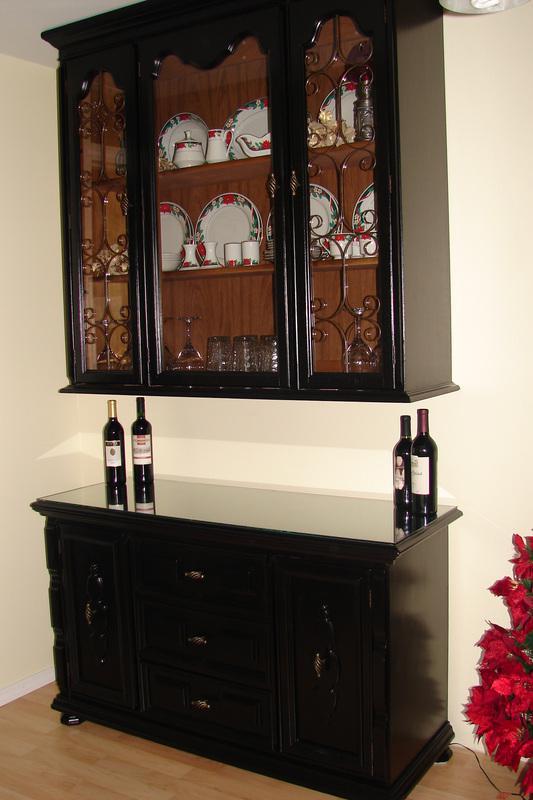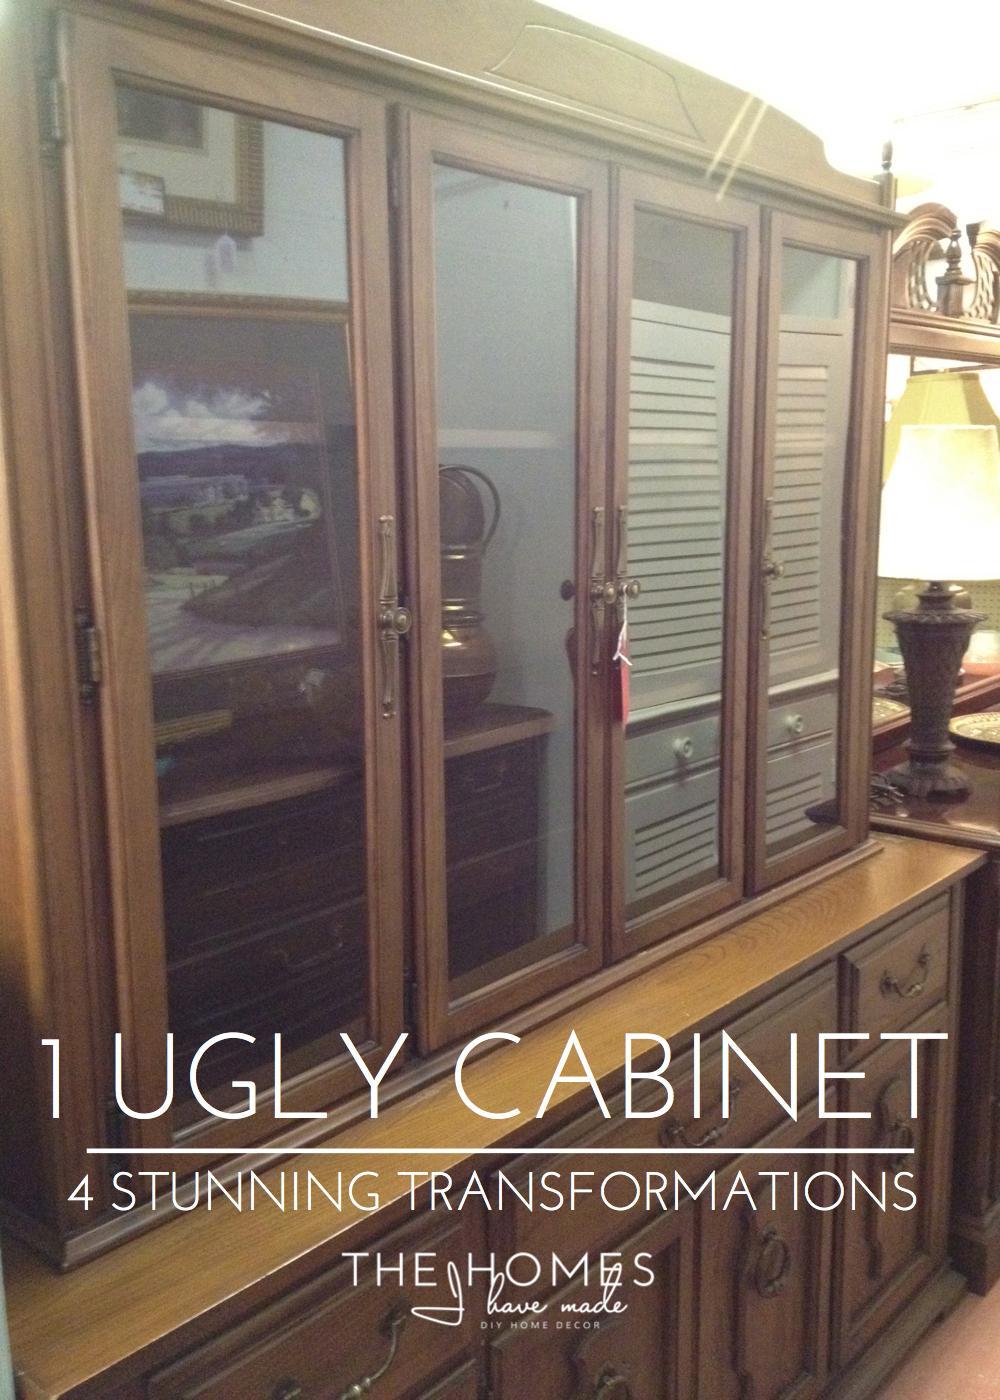The first image is the image on the left, the second image is the image on the right. Assess this claim about the two images: "One of the images includes warm-colored flowers.". Correct or not? Answer yes or no. Yes. The first image is the image on the left, the second image is the image on the right. Examine the images to the left and right. Is the description "The cabinet on the left is visibly full of dishes, and the one on the right is not." accurate? Answer yes or no. Yes. The first image is the image on the left, the second image is the image on the right. Assess this claim about the two images: "A low wooden cabinet in one image is made from the top of a larger hutch, sits on low rounded feet, and has four doors with long arched glass inserts.". Correct or not? Answer yes or no. No. The first image is the image on the left, the second image is the image on the right. Considering the images on both sides, is "An image shows a flat-topped grayish cabinet with something round on the wall behind it and nothing inside it." valid? Answer yes or no. No. 